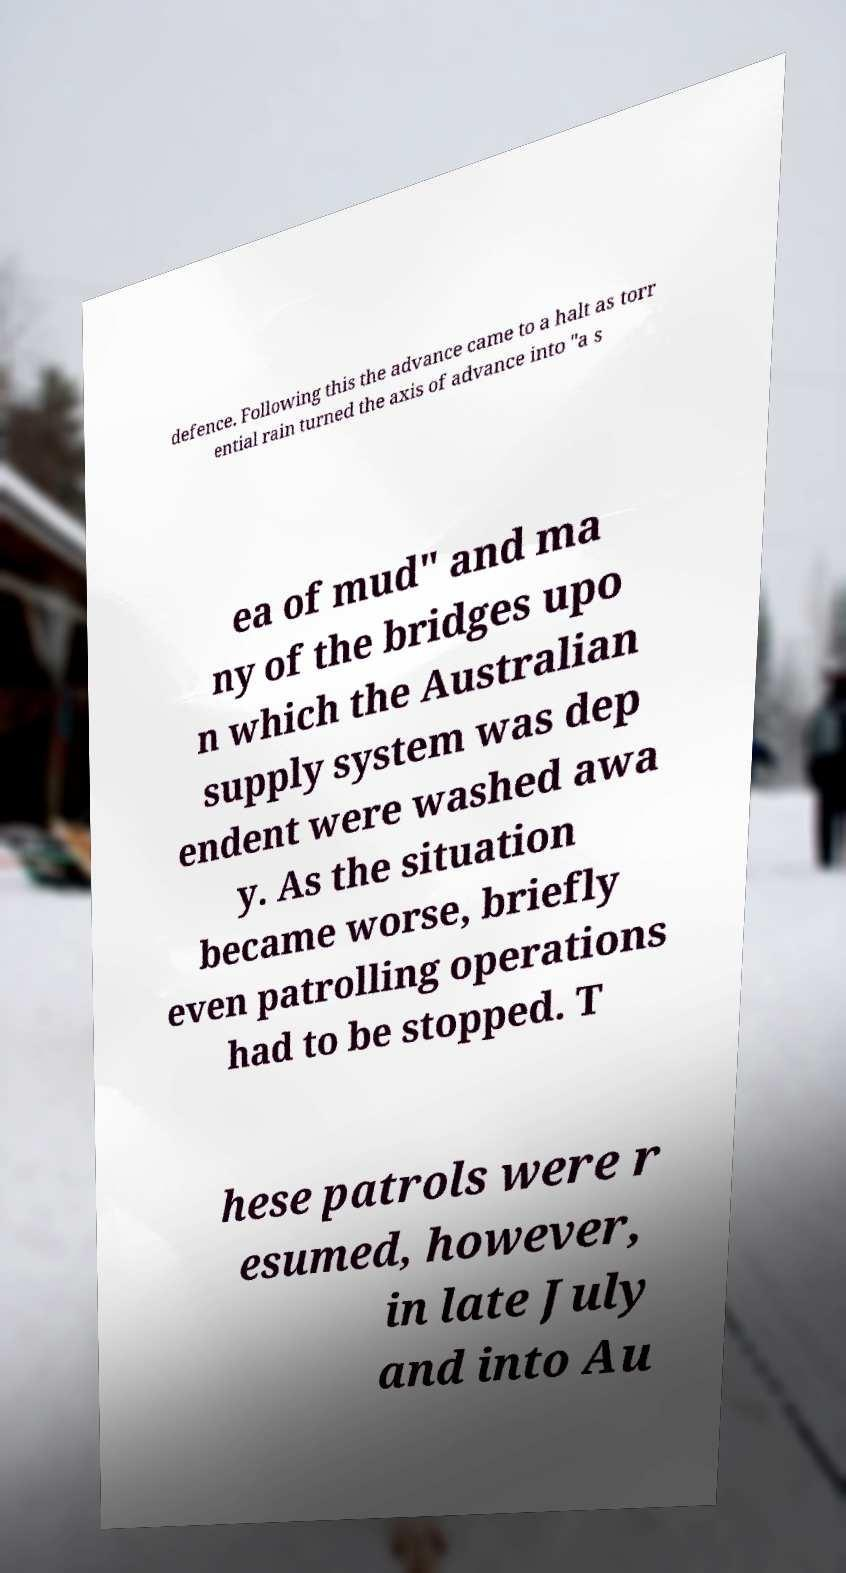For documentation purposes, I need the text within this image transcribed. Could you provide that? defence. Following this the advance came to a halt as torr ential rain turned the axis of advance into "a s ea of mud" and ma ny of the bridges upo n which the Australian supply system was dep endent were washed awa y. As the situation became worse, briefly even patrolling operations had to be stopped. T hese patrols were r esumed, however, in late July and into Au 